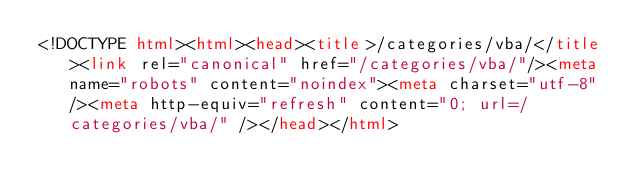Convert code to text. <code><loc_0><loc_0><loc_500><loc_500><_HTML_><!DOCTYPE html><html><head><title>/categories/vba/</title><link rel="canonical" href="/categories/vba/"/><meta name="robots" content="noindex"><meta charset="utf-8" /><meta http-equiv="refresh" content="0; url=/categories/vba/" /></head></html></code> 